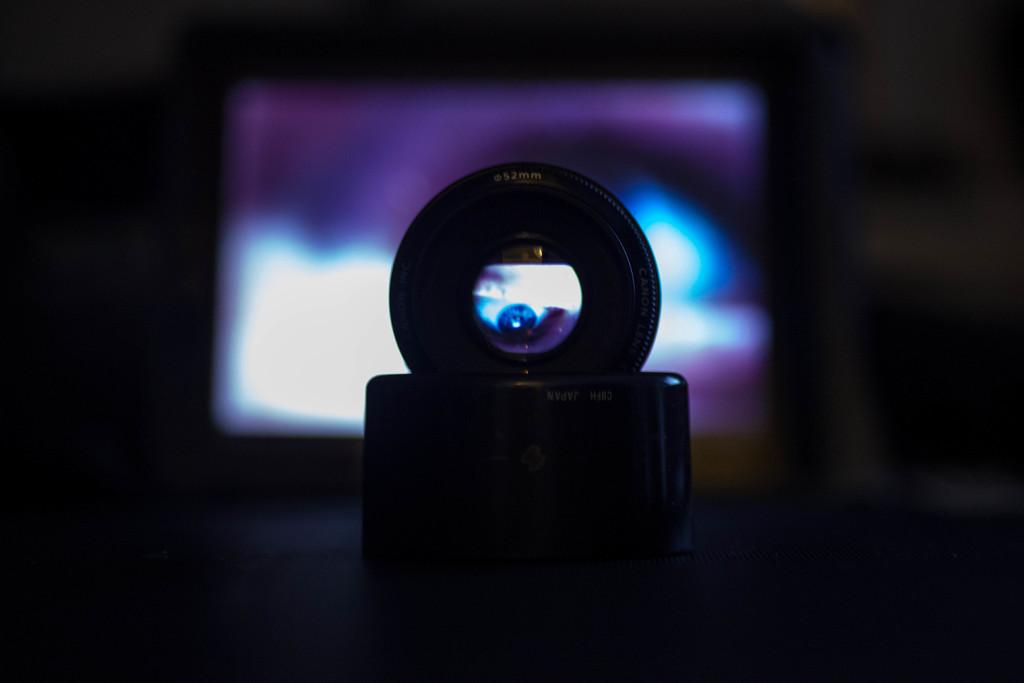What object is the main subject of the image? There is a camera in the image. Where is the camera located? The camera is placed on a table. What is in front of the camera? There is a screen in front of the camera. Can you describe the visibility of the screen? The screen is not clearly visible. Is there any smoke coming from the camera in the image? There is no smoke present in the image. What type of trouble is the camera experiencing in the image? The image does not indicate any trouble with the camera. 